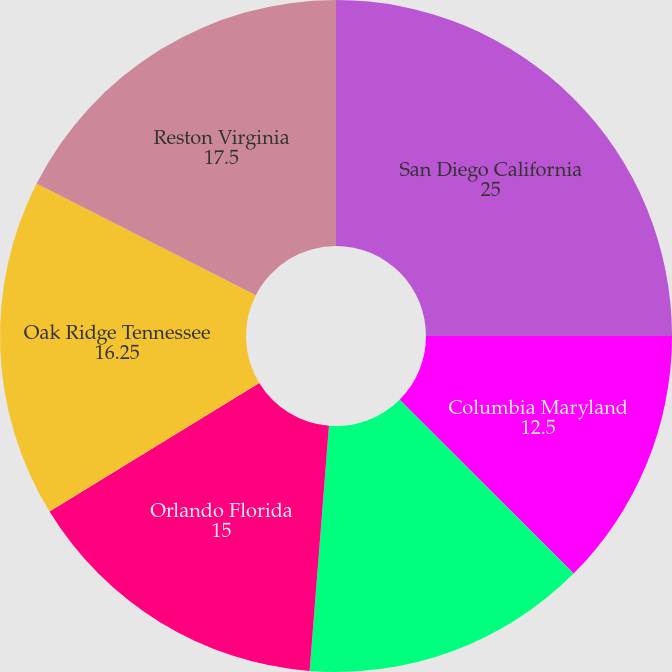Convert chart to OTSL. <chart><loc_0><loc_0><loc_500><loc_500><pie_chart><fcel>San Diego California<fcel>Columbia Maryland<fcel>Colorado Springs Colorado<fcel>Orlando Florida<fcel>Oak Ridge Tennessee<fcel>Reston Virginia<nl><fcel>25.0%<fcel>12.5%<fcel>13.75%<fcel>15.0%<fcel>16.25%<fcel>17.5%<nl></chart> 